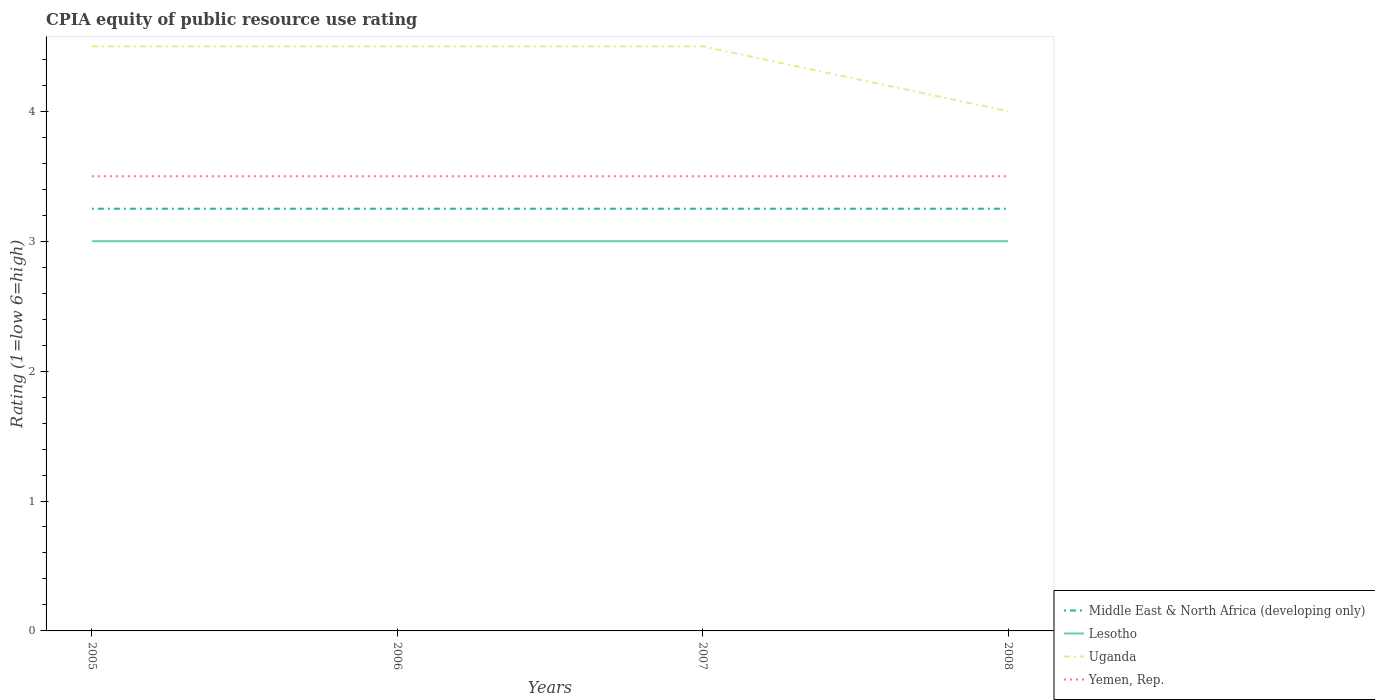How many different coloured lines are there?
Keep it short and to the point. 4. Does the line corresponding to Yemen, Rep. intersect with the line corresponding to Lesotho?
Offer a very short reply. No. Is the number of lines equal to the number of legend labels?
Offer a terse response. Yes. What is the total CPIA rating in Yemen, Rep. in the graph?
Your answer should be very brief. 0. Is the CPIA rating in Uganda strictly greater than the CPIA rating in Middle East & North Africa (developing only) over the years?
Your answer should be compact. No. How many lines are there?
Provide a short and direct response. 4. Are the values on the major ticks of Y-axis written in scientific E-notation?
Keep it short and to the point. No. Where does the legend appear in the graph?
Your response must be concise. Bottom right. How are the legend labels stacked?
Offer a very short reply. Vertical. What is the title of the graph?
Your response must be concise. CPIA equity of public resource use rating. What is the label or title of the X-axis?
Your response must be concise. Years. What is the label or title of the Y-axis?
Offer a very short reply. Rating (1=low 6=high). What is the Rating (1=low 6=high) of Lesotho in 2005?
Provide a short and direct response. 3. What is the Rating (1=low 6=high) in Yemen, Rep. in 2005?
Make the answer very short. 3.5. What is the Rating (1=low 6=high) in Middle East & North Africa (developing only) in 2006?
Provide a succinct answer. 3.25. What is the Rating (1=low 6=high) of Uganda in 2006?
Make the answer very short. 4.5. What is the Rating (1=low 6=high) in Yemen, Rep. in 2006?
Make the answer very short. 3.5. What is the Rating (1=low 6=high) of Lesotho in 2007?
Offer a terse response. 3. What is the Rating (1=low 6=high) in Uganda in 2007?
Your answer should be very brief. 4.5. What is the Rating (1=low 6=high) of Yemen, Rep. in 2007?
Keep it short and to the point. 3.5. What is the Rating (1=low 6=high) in Uganda in 2008?
Make the answer very short. 4. What is the Rating (1=low 6=high) of Yemen, Rep. in 2008?
Your answer should be very brief. 3.5. Across all years, what is the maximum Rating (1=low 6=high) in Lesotho?
Ensure brevity in your answer.  3. Across all years, what is the maximum Rating (1=low 6=high) in Uganda?
Offer a terse response. 4.5. Across all years, what is the maximum Rating (1=low 6=high) in Yemen, Rep.?
Provide a short and direct response. 3.5. Across all years, what is the minimum Rating (1=low 6=high) in Uganda?
Give a very brief answer. 4. What is the total Rating (1=low 6=high) in Middle East & North Africa (developing only) in the graph?
Ensure brevity in your answer.  13. What is the total Rating (1=low 6=high) of Lesotho in the graph?
Your response must be concise. 12. What is the difference between the Rating (1=low 6=high) in Middle East & North Africa (developing only) in 2005 and that in 2007?
Provide a succinct answer. 0. What is the difference between the Rating (1=low 6=high) of Yemen, Rep. in 2005 and that in 2007?
Make the answer very short. 0. What is the difference between the Rating (1=low 6=high) in Lesotho in 2005 and that in 2008?
Your answer should be very brief. 0. What is the difference between the Rating (1=low 6=high) in Middle East & North Africa (developing only) in 2006 and that in 2007?
Make the answer very short. 0. What is the difference between the Rating (1=low 6=high) in Lesotho in 2006 and that in 2008?
Your response must be concise. 0. What is the difference between the Rating (1=low 6=high) in Uganda in 2006 and that in 2008?
Provide a short and direct response. 0.5. What is the difference between the Rating (1=low 6=high) of Uganda in 2007 and that in 2008?
Your answer should be compact. 0.5. What is the difference between the Rating (1=low 6=high) in Middle East & North Africa (developing only) in 2005 and the Rating (1=low 6=high) in Lesotho in 2006?
Your response must be concise. 0.25. What is the difference between the Rating (1=low 6=high) of Middle East & North Africa (developing only) in 2005 and the Rating (1=low 6=high) of Uganda in 2006?
Make the answer very short. -1.25. What is the difference between the Rating (1=low 6=high) of Middle East & North Africa (developing only) in 2005 and the Rating (1=low 6=high) of Yemen, Rep. in 2006?
Offer a very short reply. -0.25. What is the difference between the Rating (1=low 6=high) in Lesotho in 2005 and the Rating (1=low 6=high) in Uganda in 2006?
Offer a very short reply. -1.5. What is the difference between the Rating (1=low 6=high) in Lesotho in 2005 and the Rating (1=low 6=high) in Yemen, Rep. in 2006?
Offer a very short reply. -0.5. What is the difference between the Rating (1=low 6=high) of Uganda in 2005 and the Rating (1=low 6=high) of Yemen, Rep. in 2006?
Offer a very short reply. 1. What is the difference between the Rating (1=low 6=high) in Middle East & North Africa (developing only) in 2005 and the Rating (1=low 6=high) in Uganda in 2007?
Your answer should be compact. -1.25. What is the difference between the Rating (1=low 6=high) in Middle East & North Africa (developing only) in 2005 and the Rating (1=low 6=high) in Yemen, Rep. in 2007?
Provide a short and direct response. -0.25. What is the difference between the Rating (1=low 6=high) in Uganda in 2005 and the Rating (1=low 6=high) in Yemen, Rep. in 2007?
Your answer should be very brief. 1. What is the difference between the Rating (1=low 6=high) in Middle East & North Africa (developing only) in 2005 and the Rating (1=low 6=high) in Lesotho in 2008?
Provide a succinct answer. 0.25. What is the difference between the Rating (1=low 6=high) of Middle East & North Africa (developing only) in 2005 and the Rating (1=low 6=high) of Uganda in 2008?
Give a very brief answer. -0.75. What is the difference between the Rating (1=low 6=high) of Lesotho in 2005 and the Rating (1=low 6=high) of Uganda in 2008?
Offer a terse response. -1. What is the difference between the Rating (1=low 6=high) in Lesotho in 2005 and the Rating (1=low 6=high) in Yemen, Rep. in 2008?
Offer a very short reply. -0.5. What is the difference between the Rating (1=low 6=high) in Middle East & North Africa (developing only) in 2006 and the Rating (1=low 6=high) in Lesotho in 2007?
Provide a succinct answer. 0.25. What is the difference between the Rating (1=low 6=high) of Middle East & North Africa (developing only) in 2006 and the Rating (1=low 6=high) of Uganda in 2007?
Ensure brevity in your answer.  -1.25. What is the difference between the Rating (1=low 6=high) of Middle East & North Africa (developing only) in 2006 and the Rating (1=low 6=high) of Yemen, Rep. in 2007?
Provide a short and direct response. -0.25. What is the difference between the Rating (1=low 6=high) in Lesotho in 2006 and the Rating (1=low 6=high) in Uganda in 2007?
Keep it short and to the point. -1.5. What is the difference between the Rating (1=low 6=high) of Lesotho in 2006 and the Rating (1=low 6=high) of Yemen, Rep. in 2007?
Ensure brevity in your answer.  -0.5. What is the difference between the Rating (1=low 6=high) of Uganda in 2006 and the Rating (1=low 6=high) of Yemen, Rep. in 2007?
Provide a short and direct response. 1. What is the difference between the Rating (1=low 6=high) in Middle East & North Africa (developing only) in 2006 and the Rating (1=low 6=high) in Uganda in 2008?
Your answer should be compact. -0.75. What is the difference between the Rating (1=low 6=high) of Uganda in 2006 and the Rating (1=low 6=high) of Yemen, Rep. in 2008?
Provide a short and direct response. 1. What is the difference between the Rating (1=low 6=high) of Middle East & North Africa (developing only) in 2007 and the Rating (1=low 6=high) of Lesotho in 2008?
Offer a very short reply. 0.25. What is the difference between the Rating (1=low 6=high) of Middle East & North Africa (developing only) in 2007 and the Rating (1=low 6=high) of Uganda in 2008?
Make the answer very short. -0.75. What is the difference between the Rating (1=low 6=high) in Middle East & North Africa (developing only) in 2007 and the Rating (1=low 6=high) in Yemen, Rep. in 2008?
Provide a succinct answer. -0.25. What is the difference between the Rating (1=low 6=high) of Lesotho in 2007 and the Rating (1=low 6=high) of Uganda in 2008?
Your answer should be compact. -1. What is the difference between the Rating (1=low 6=high) of Lesotho in 2007 and the Rating (1=low 6=high) of Yemen, Rep. in 2008?
Ensure brevity in your answer.  -0.5. What is the difference between the Rating (1=low 6=high) in Uganda in 2007 and the Rating (1=low 6=high) in Yemen, Rep. in 2008?
Keep it short and to the point. 1. What is the average Rating (1=low 6=high) in Lesotho per year?
Offer a terse response. 3. What is the average Rating (1=low 6=high) in Uganda per year?
Your response must be concise. 4.38. What is the average Rating (1=low 6=high) in Yemen, Rep. per year?
Your response must be concise. 3.5. In the year 2005, what is the difference between the Rating (1=low 6=high) in Middle East & North Africa (developing only) and Rating (1=low 6=high) in Lesotho?
Make the answer very short. 0.25. In the year 2005, what is the difference between the Rating (1=low 6=high) of Middle East & North Africa (developing only) and Rating (1=low 6=high) of Uganda?
Make the answer very short. -1.25. In the year 2005, what is the difference between the Rating (1=low 6=high) of Lesotho and Rating (1=low 6=high) of Uganda?
Keep it short and to the point. -1.5. In the year 2006, what is the difference between the Rating (1=low 6=high) in Middle East & North Africa (developing only) and Rating (1=low 6=high) in Lesotho?
Your answer should be very brief. 0.25. In the year 2006, what is the difference between the Rating (1=low 6=high) of Middle East & North Africa (developing only) and Rating (1=low 6=high) of Uganda?
Offer a terse response. -1.25. In the year 2006, what is the difference between the Rating (1=low 6=high) in Lesotho and Rating (1=low 6=high) in Uganda?
Offer a very short reply. -1.5. In the year 2007, what is the difference between the Rating (1=low 6=high) of Middle East & North Africa (developing only) and Rating (1=low 6=high) of Lesotho?
Make the answer very short. 0.25. In the year 2007, what is the difference between the Rating (1=low 6=high) in Middle East & North Africa (developing only) and Rating (1=low 6=high) in Uganda?
Give a very brief answer. -1.25. In the year 2007, what is the difference between the Rating (1=low 6=high) of Middle East & North Africa (developing only) and Rating (1=low 6=high) of Yemen, Rep.?
Offer a very short reply. -0.25. In the year 2007, what is the difference between the Rating (1=low 6=high) in Lesotho and Rating (1=low 6=high) in Yemen, Rep.?
Give a very brief answer. -0.5. In the year 2008, what is the difference between the Rating (1=low 6=high) of Middle East & North Africa (developing only) and Rating (1=low 6=high) of Uganda?
Your answer should be very brief. -0.75. In the year 2008, what is the difference between the Rating (1=low 6=high) in Lesotho and Rating (1=low 6=high) in Uganda?
Your answer should be compact. -1. In the year 2008, what is the difference between the Rating (1=low 6=high) of Lesotho and Rating (1=low 6=high) of Yemen, Rep.?
Give a very brief answer. -0.5. What is the ratio of the Rating (1=low 6=high) of Middle East & North Africa (developing only) in 2005 to that in 2006?
Ensure brevity in your answer.  1. What is the ratio of the Rating (1=low 6=high) in Lesotho in 2005 to that in 2006?
Keep it short and to the point. 1. What is the ratio of the Rating (1=low 6=high) of Uganda in 2005 to that in 2006?
Offer a terse response. 1. What is the ratio of the Rating (1=low 6=high) in Lesotho in 2005 to that in 2007?
Offer a very short reply. 1. What is the ratio of the Rating (1=low 6=high) in Yemen, Rep. in 2005 to that in 2007?
Keep it short and to the point. 1. What is the ratio of the Rating (1=low 6=high) of Middle East & North Africa (developing only) in 2005 to that in 2008?
Give a very brief answer. 1. What is the ratio of the Rating (1=low 6=high) of Lesotho in 2005 to that in 2008?
Offer a terse response. 1. What is the ratio of the Rating (1=low 6=high) in Uganda in 2005 to that in 2008?
Ensure brevity in your answer.  1.12. What is the ratio of the Rating (1=low 6=high) in Middle East & North Africa (developing only) in 2006 to that in 2007?
Provide a succinct answer. 1. What is the ratio of the Rating (1=low 6=high) in Uganda in 2006 to that in 2007?
Provide a succinct answer. 1. What is the ratio of the Rating (1=low 6=high) in Yemen, Rep. in 2006 to that in 2007?
Make the answer very short. 1. What is the ratio of the Rating (1=low 6=high) in Middle East & North Africa (developing only) in 2006 to that in 2008?
Provide a succinct answer. 1. What is the ratio of the Rating (1=low 6=high) of Uganda in 2006 to that in 2008?
Keep it short and to the point. 1.12. What is the ratio of the Rating (1=low 6=high) of Lesotho in 2007 to that in 2008?
Your answer should be very brief. 1. What is the ratio of the Rating (1=low 6=high) in Yemen, Rep. in 2007 to that in 2008?
Provide a short and direct response. 1. What is the difference between the highest and the second highest Rating (1=low 6=high) in Middle East & North Africa (developing only)?
Offer a terse response. 0. What is the difference between the highest and the second highest Rating (1=low 6=high) in Lesotho?
Give a very brief answer. 0. What is the difference between the highest and the second highest Rating (1=low 6=high) of Uganda?
Keep it short and to the point. 0. What is the difference between the highest and the lowest Rating (1=low 6=high) of Middle East & North Africa (developing only)?
Offer a very short reply. 0. What is the difference between the highest and the lowest Rating (1=low 6=high) of Lesotho?
Provide a succinct answer. 0. What is the difference between the highest and the lowest Rating (1=low 6=high) in Uganda?
Provide a succinct answer. 0.5. 